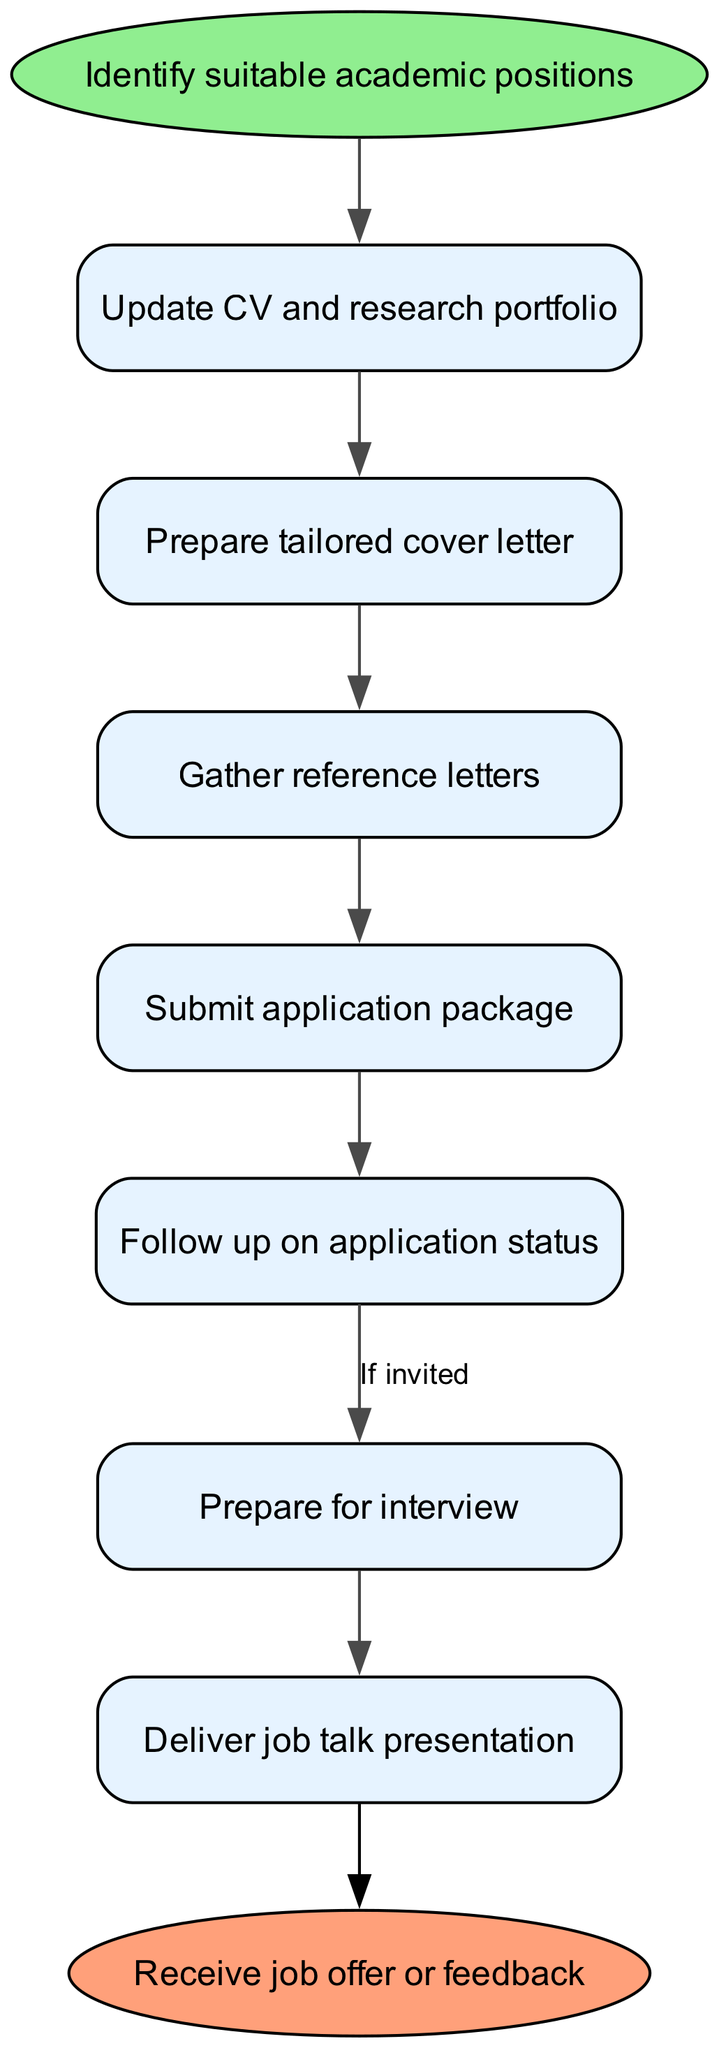What is the first step in the job application workflow? The first step, as indicated in the diagram, is labeled as "Identify suitable academic positions." This is the starting point of the workflow before moving on to updating the CV.
Answer: Identify suitable academic positions How many nodes are in the job application workflow? The diagram includes a total of seven nodes representing different stages of the workflow, in addition to the start and end nodes. Therefore, 7 nodes are present in the main workflow.
Answer: 7 What do you do after preparing a tailored cover letter? After preparing a tailored cover letter, the next step indicated in the diagram is to "Gather reference letters." This is directly connected to the cover letter preparation node.
Answer: Gather reference letters What happens if you are invited after submitting your application package? If you are invited after submitting the application package, the next step is to "Prepare for interview." This follows the edge labeled "If invited," indicating that the following steps depend on this invitation.
Answer: Prepare for interview What is the relationship between submitting the application package and following up on application status? The relationship, as shown in the diagram, is sequential; following the submission of the application package, you then "Follow up on application status." This indicates a direct progression from one activity to the next.
Answer: Follow up on application status Which node leads directly to the end node? The node that leads directly to the end node is "Deliver job talk presentation." This is the last action in the workflow that connects to receiving a job offer or feedback.
Answer: Deliver job talk presentation How many edges connect the nodes in the workflow? There are a total of six edges connecting the various nodes of the workflow which indicate the flow of actions from one step to the next, plus one additional edge that leads to the end node, making it a total of seven edges.
Answer: 7 What step follows gathering reference letters? The step that follows gathering reference letters in the workflow is "Submit application package," which is directly connected to the reference letters node.
Answer: Submit application package What is the final outcome of the workflow? The final outcome of this job application workflow is "Receive job offer or feedback," which signifies the end of the process after all prior steps have been completed successfully.
Answer: Receive job offer or feedback 